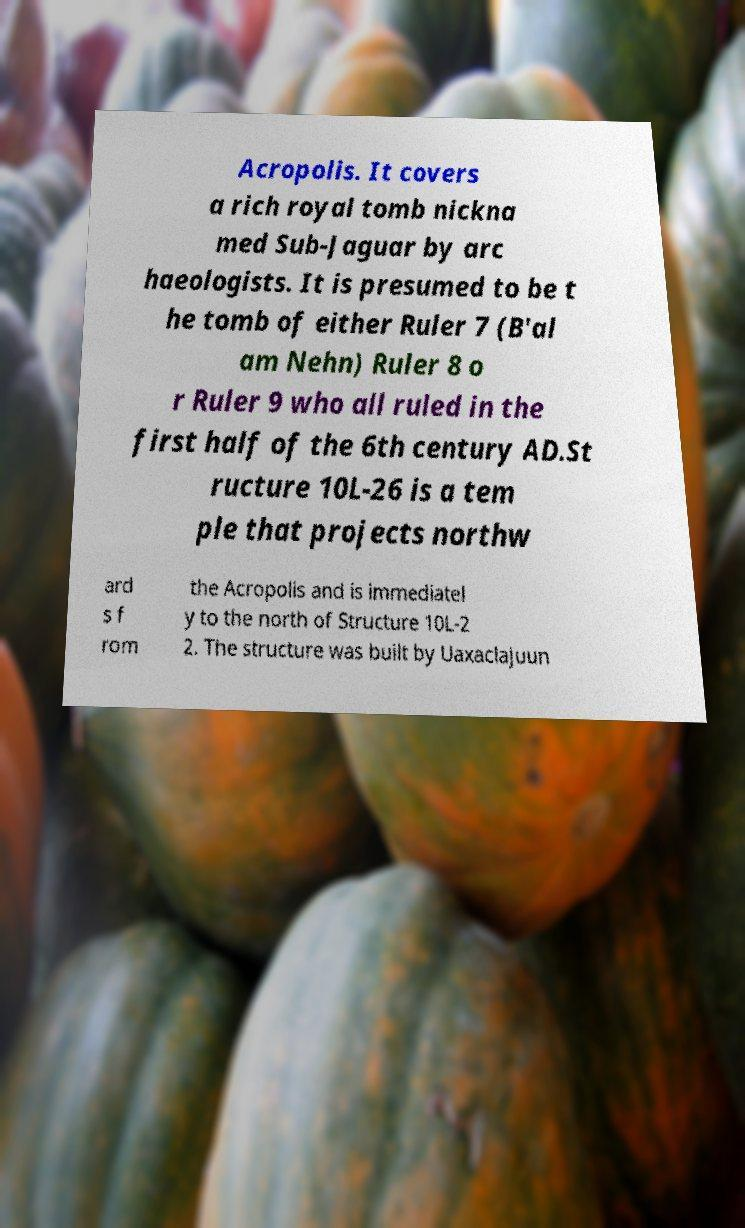There's text embedded in this image that I need extracted. Can you transcribe it verbatim? Acropolis. It covers a rich royal tomb nickna med Sub-Jaguar by arc haeologists. It is presumed to be t he tomb of either Ruler 7 (B'al am Nehn) Ruler 8 o r Ruler 9 who all ruled in the first half of the 6th century AD.St ructure 10L-26 is a tem ple that projects northw ard s f rom the Acropolis and is immediatel y to the north of Structure 10L-2 2. The structure was built by Uaxaclajuun 